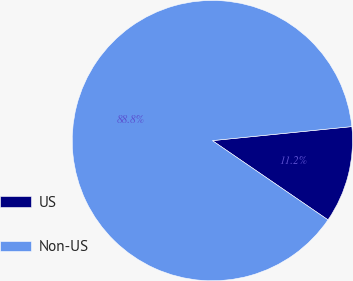Convert chart to OTSL. <chart><loc_0><loc_0><loc_500><loc_500><pie_chart><fcel>US<fcel>Non-US<nl><fcel>11.16%<fcel>88.84%<nl></chart> 